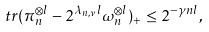<formula> <loc_0><loc_0><loc_500><loc_500>\ t r ( \pi _ { n } ^ { \otimes l } - 2 ^ { \lambda _ { n , \nu } l } \omega _ { n } ^ { \otimes l } ) _ { + } \leq 2 ^ { - \gamma n l } ,</formula> 